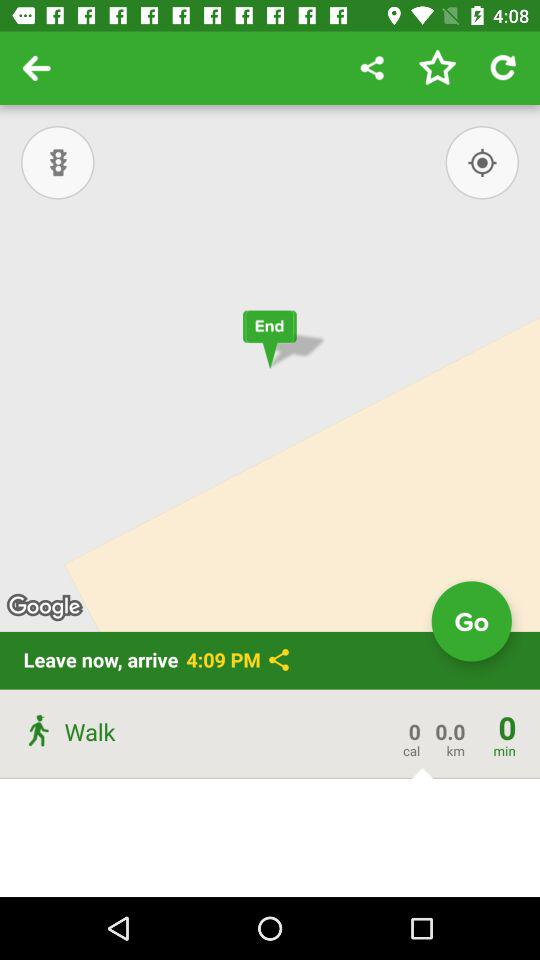What is the traveled distance? The traveled distance is 0 km. 